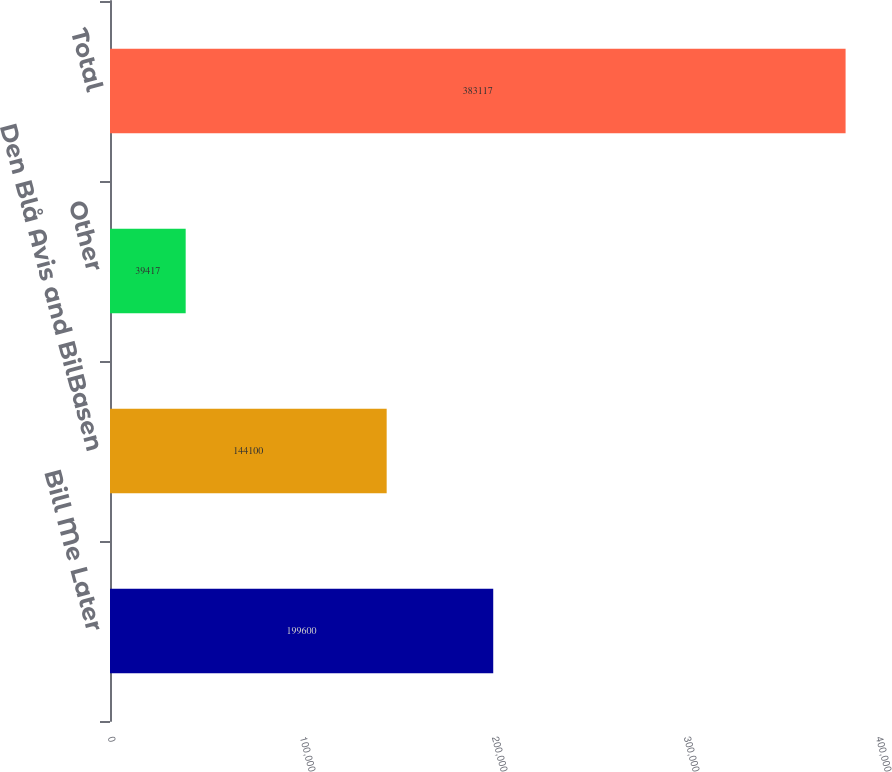Convert chart to OTSL. <chart><loc_0><loc_0><loc_500><loc_500><bar_chart><fcel>Bill Me Later<fcel>Den Blå Avis and BilBasen<fcel>Other<fcel>Total<nl><fcel>199600<fcel>144100<fcel>39417<fcel>383117<nl></chart> 